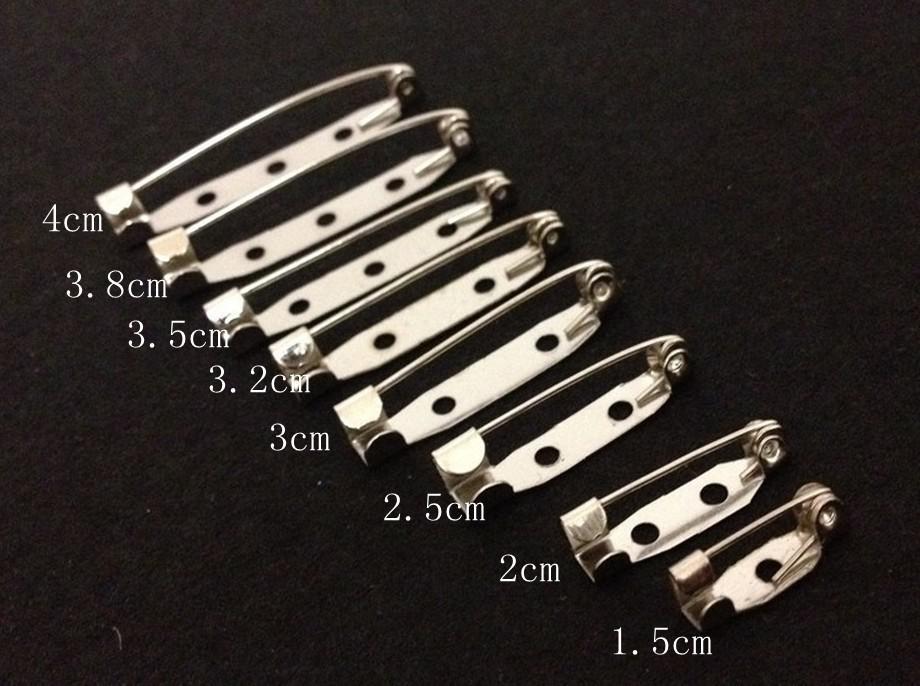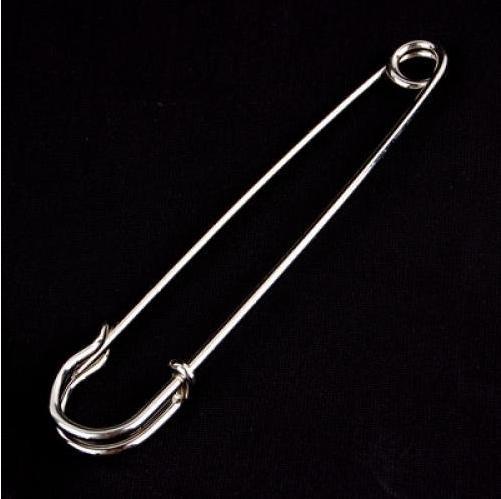The first image is the image on the left, the second image is the image on the right. For the images displayed, is the sentence "There are at least four pins in the image on the right." factually correct? Answer yes or no. No. 